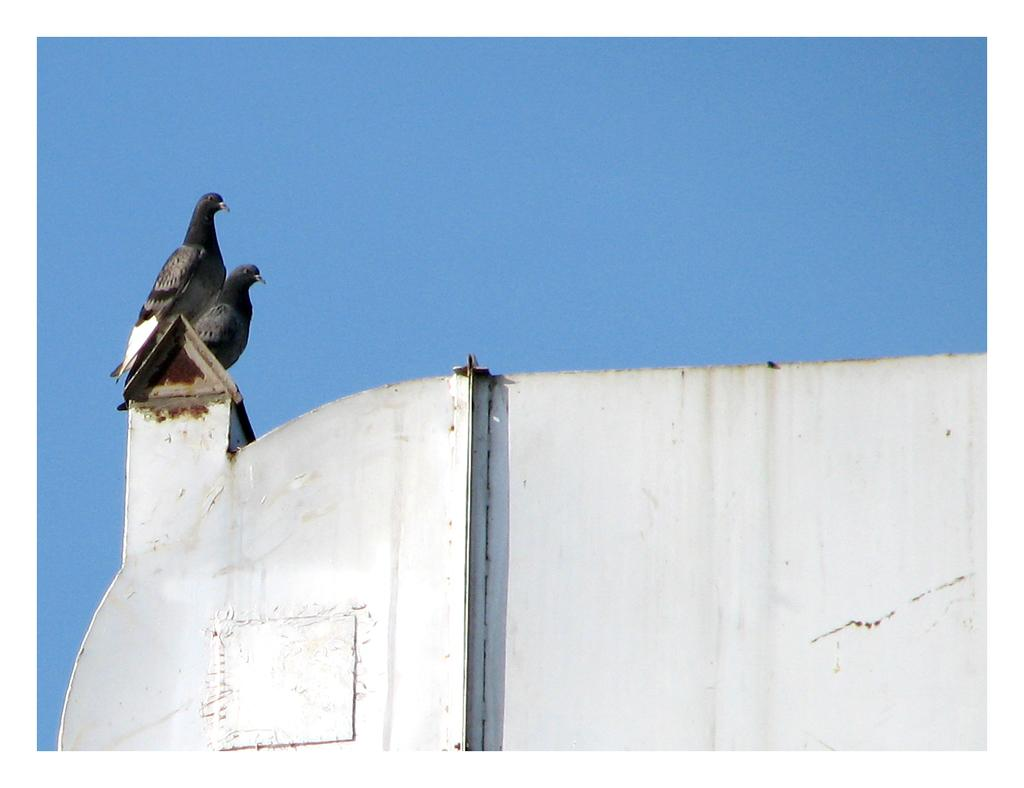What type of animals can be seen in the image? There are pigeons in the image. Where are the pigeons located? The pigeons are standing on a wall. What can be seen in the background of the image? The sky is visible in the background of the image. What type of flower is being squeezed for juice in the image? There is no flower or juice present in the image; it features pigeons standing on a wall with the sky visible in the background. 